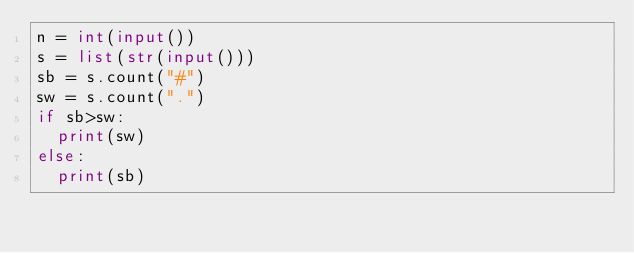Convert code to text. <code><loc_0><loc_0><loc_500><loc_500><_Python_>n = int(input())
s = list(str(input()))
sb = s.count("#")
sw = s.count(".")
if sb>sw:
  print(sw)
else:
  print(sb)</code> 